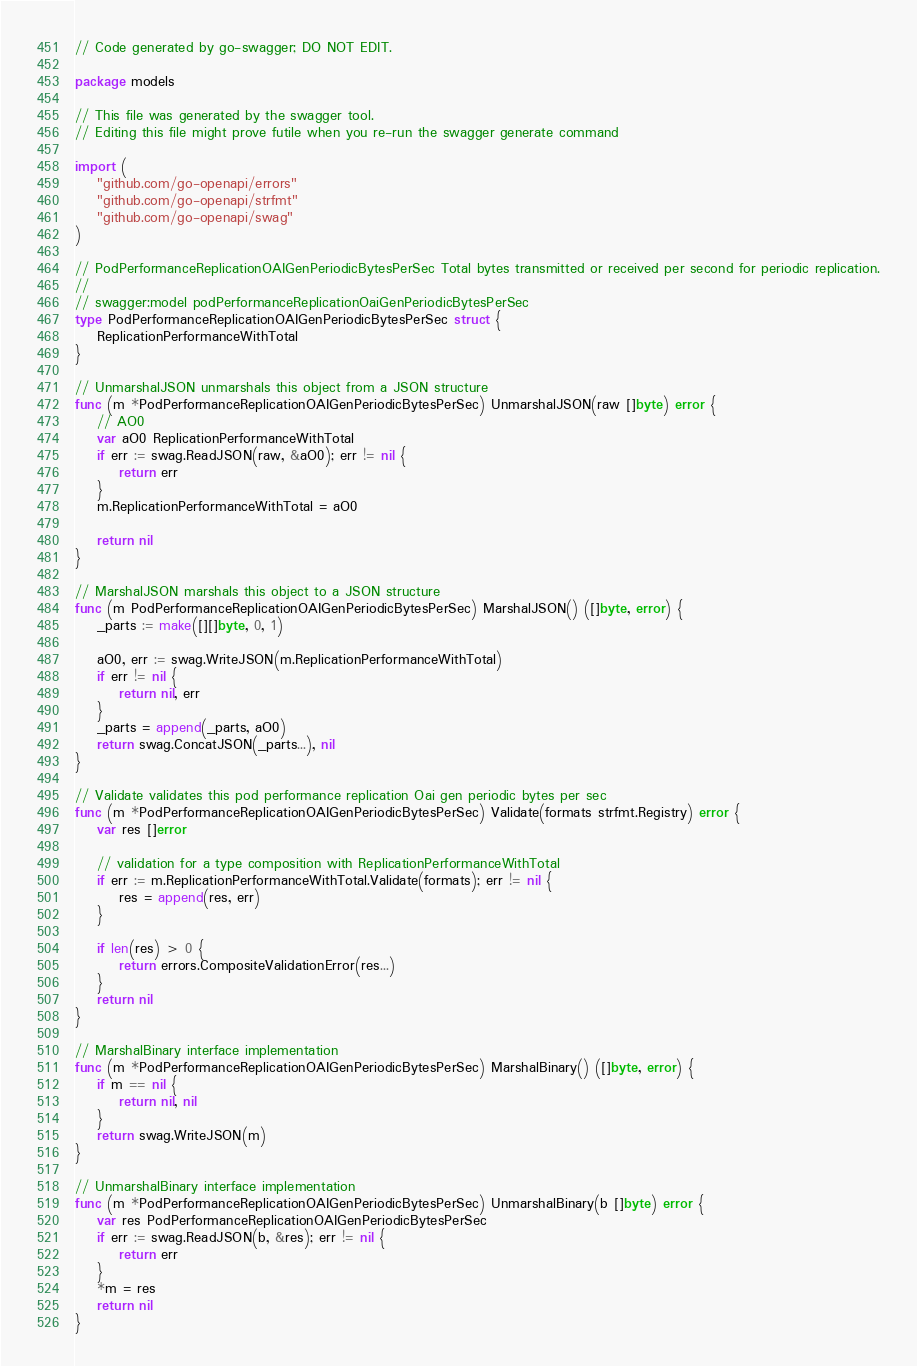Convert code to text. <code><loc_0><loc_0><loc_500><loc_500><_Go_>// Code generated by go-swagger; DO NOT EDIT.

package models

// This file was generated by the swagger tool.
// Editing this file might prove futile when you re-run the swagger generate command

import (
	"github.com/go-openapi/errors"
	"github.com/go-openapi/strfmt"
	"github.com/go-openapi/swag"
)

// PodPerformanceReplicationOAIGenPeriodicBytesPerSec Total bytes transmitted or received per second for periodic replication.
//
// swagger:model podPerformanceReplicationOaiGenPeriodicBytesPerSec
type PodPerformanceReplicationOAIGenPeriodicBytesPerSec struct {
	ReplicationPerformanceWithTotal
}

// UnmarshalJSON unmarshals this object from a JSON structure
func (m *PodPerformanceReplicationOAIGenPeriodicBytesPerSec) UnmarshalJSON(raw []byte) error {
	// AO0
	var aO0 ReplicationPerformanceWithTotal
	if err := swag.ReadJSON(raw, &aO0); err != nil {
		return err
	}
	m.ReplicationPerformanceWithTotal = aO0

	return nil
}

// MarshalJSON marshals this object to a JSON structure
func (m PodPerformanceReplicationOAIGenPeriodicBytesPerSec) MarshalJSON() ([]byte, error) {
	_parts := make([][]byte, 0, 1)

	aO0, err := swag.WriteJSON(m.ReplicationPerformanceWithTotal)
	if err != nil {
		return nil, err
	}
	_parts = append(_parts, aO0)
	return swag.ConcatJSON(_parts...), nil
}

// Validate validates this pod performance replication Oai gen periodic bytes per sec
func (m *PodPerformanceReplicationOAIGenPeriodicBytesPerSec) Validate(formats strfmt.Registry) error {
	var res []error

	// validation for a type composition with ReplicationPerformanceWithTotal
	if err := m.ReplicationPerformanceWithTotal.Validate(formats); err != nil {
		res = append(res, err)
	}

	if len(res) > 0 {
		return errors.CompositeValidationError(res...)
	}
	return nil
}

// MarshalBinary interface implementation
func (m *PodPerformanceReplicationOAIGenPeriodicBytesPerSec) MarshalBinary() ([]byte, error) {
	if m == nil {
		return nil, nil
	}
	return swag.WriteJSON(m)
}

// UnmarshalBinary interface implementation
func (m *PodPerformanceReplicationOAIGenPeriodicBytesPerSec) UnmarshalBinary(b []byte) error {
	var res PodPerformanceReplicationOAIGenPeriodicBytesPerSec
	if err := swag.ReadJSON(b, &res); err != nil {
		return err
	}
	*m = res
	return nil
}
</code> 